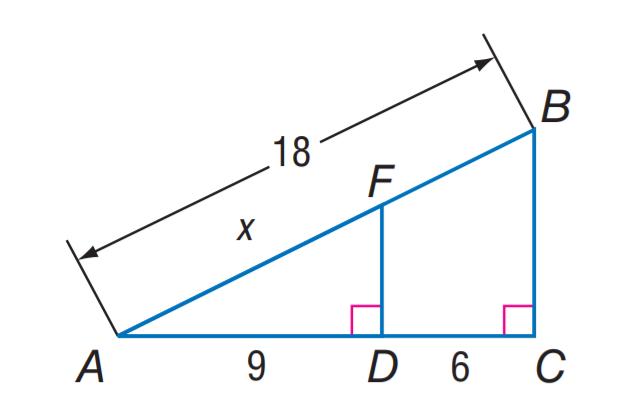Answer the mathemtical geometry problem and directly provide the correct option letter.
Question: Find A F.
Choices: A: 9 B: 10.8 C: 18 D: 21.6 B 